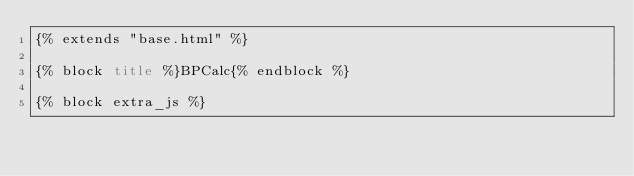<code> <loc_0><loc_0><loc_500><loc_500><_HTML_>{% extends "base.html" %}

{% block title %}BPCalc{% endblock %}

{% block extra_js %}</code> 